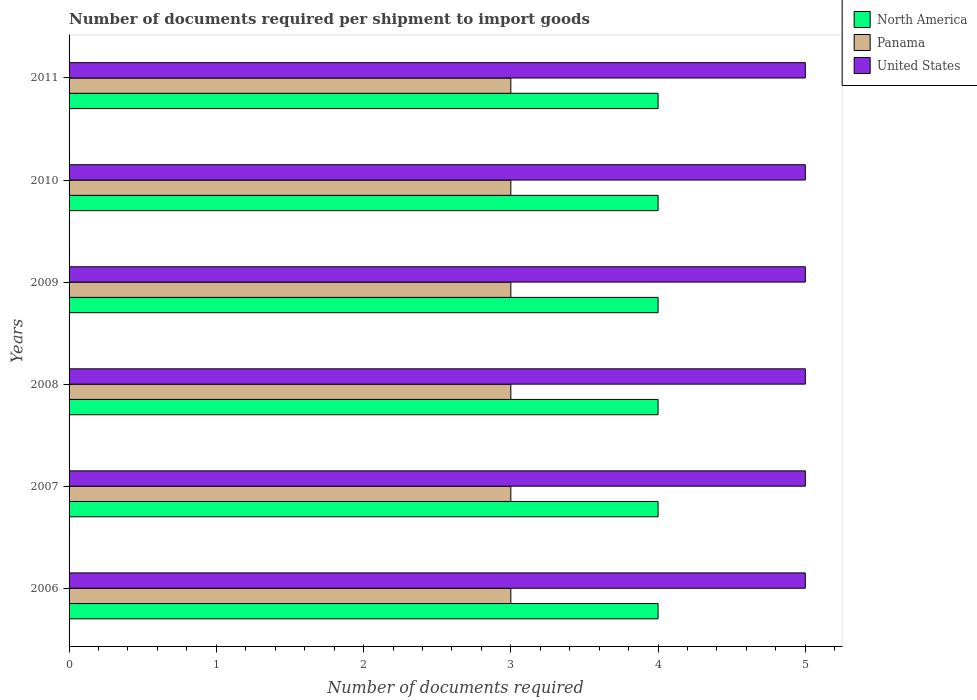How many different coloured bars are there?
Give a very brief answer. 3. Are the number of bars on each tick of the Y-axis equal?
Ensure brevity in your answer.  Yes. How many bars are there on the 3rd tick from the top?
Make the answer very short. 3. How many bars are there on the 4th tick from the bottom?
Provide a succinct answer. 3. What is the label of the 6th group of bars from the top?
Give a very brief answer. 2006. What is the number of documents required per shipment to import goods in Panama in 2006?
Your answer should be compact. 3. Across all years, what is the maximum number of documents required per shipment to import goods in United States?
Your answer should be compact. 5. Across all years, what is the minimum number of documents required per shipment to import goods in Panama?
Provide a short and direct response. 3. What is the total number of documents required per shipment to import goods in North America in the graph?
Give a very brief answer. 24. What is the difference between the number of documents required per shipment to import goods in Panama in 2006 and that in 2008?
Your answer should be compact. 0. What is the difference between the number of documents required per shipment to import goods in Panama in 2010 and the number of documents required per shipment to import goods in United States in 2007?
Give a very brief answer. -2. What is the average number of documents required per shipment to import goods in North America per year?
Keep it short and to the point. 4. In the year 2008, what is the difference between the number of documents required per shipment to import goods in North America and number of documents required per shipment to import goods in Panama?
Give a very brief answer. 1. In how many years, is the number of documents required per shipment to import goods in United States greater than 2.8 ?
Offer a very short reply. 6. What does the 2nd bar from the top in 2007 represents?
Your response must be concise. Panama. What does the 2nd bar from the bottom in 2009 represents?
Your answer should be compact. Panama. Is it the case that in every year, the sum of the number of documents required per shipment to import goods in North America and number of documents required per shipment to import goods in United States is greater than the number of documents required per shipment to import goods in Panama?
Give a very brief answer. Yes. How many bars are there?
Offer a terse response. 18. Are the values on the major ticks of X-axis written in scientific E-notation?
Offer a very short reply. No. Where does the legend appear in the graph?
Keep it short and to the point. Top right. What is the title of the graph?
Your response must be concise. Number of documents required per shipment to import goods. What is the label or title of the X-axis?
Provide a short and direct response. Number of documents required. What is the label or title of the Y-axis?
Offer a very short reply. Years. What is the Number of documents required in United States in 2006?
Your answer should be compact. 5. What is the Number of documents required of Panama in 2007?
Make the answer very short. 3. What is the Number of documents required of United States in 2010?
Your answer should be very brief. 5. Across all years, what is the maximum Number of documents required of Panama?
Offer a terse response. 3. Across all years, what is the maximum Number of documents required of United States?
Keep it short and to the point. 5. Across all years, what is the minimum Number of documents required of North America?
Your answer should be compact. 4. What is the total Number of documents required of North America in the graph?
Your answer should be compact. 24. What is the total Number of documents required of United States in the graph?
Ensure brevity in your answer.  30. What is the difference between the Number of documents required of North America in 2006 and that in 2007?
Keep it short and to the point. 0. What is the difference between the Number of documents required in Panama in 2006 and that in 2007?
Make the answer very short. 0. What is the difference between the Number of documents required of United States in 2006 and that in 2007?
Offer a terse response. 0. What is the difference between the Number of documents required of North America in 2006 and that in 2008?
Ensure brevity in your answer.  0. What is the difference between the Number of documents required of United States in 2006 and that in 2008?
Your response must be concise. 0. What is the difference between the Number of documents required in North America in 2006 and that in 2009?
Make the answer very short. 0. What is the difference between the Number of documents required in Panama in 2006 and that in 2009?
Provide a succinct answer. 0. What is the difference between the Number of documents required in United States in 2006 and that in 2009?
Your answer should be compact. 0. What is the difference between the Number of documents required in North America in 2006 and that in 2011?
Provide a succinct answer. 0. What is the difference between the Number of documents required of Panama in 2006 and that in 2011?
Your answer should be very brief. 0. What is the difference between the Number of documents required of North America in 2007 and that in 2008?
Provide a succinct answer. 0. What is the difference between the Number of documents required in Panama in 2007 and that in 2008?
Provide a succinct answer. 0. What is the difference between the Number of documents required of North America in 2007 and that in 2009?
Offer a terse response. 0. What is the difference between the Number of documents required of Panama in 2007 and that in 2009?
Provide a succinct answer. 0. What is the difference between the Number of documents required in United States in 2007 and that in 2009?
Provide a succinct answer. 0. What is the difference between the Number of documents required in United States in 2007 and that in 2010?
Provide a succinct answer. 0. What is the difference between the Number of documents required of North America in 2007 and that in 2011?
Ensure brevity in your answer.  0. What is the difference between the Number of documents required of Panama in 2007 and that in 2011?
Your response must be concise. 0. What is the difference between the Number of documents required of United States in 2007 and that in 2011?
Offer a terse response. 0. What is the difference between the Number of documents required of North America in 2008 and that in 2010?
Provide a succinct answer. 0. What is the difference between the Number of documents required in North America in 2008 and that in 2011?
Make the answer very short. 0. What is the difference between the Number of documents required in Panama in 2008 and that in 2011?
Make the answer very short. 0. What is the difference between the Number of documents required in United States in 2008 and that in 2011?
Your answer should be compact. 0. What is the difference between the Number of documents required in North America in 2009 and that in 2010?
Provide a short and direct response. 0. What is the difference between the Number of documents required of Panama in 2009 and that in 2010?
Keep it short and to the point. 0. What is the difference between the Number of documents required in United States in 2009 and that in 2010?
Keep it short and to the point. 0. What is the difference between the Number of documents required in North America in 2009 and that in 2011?
Keep it short and to the point. 0. What is the difference between the Number of documents required in North America in 2010 and that in 2011?
Offer a terse response. 0. What is the difference between the Number of documents required in North America in 2006 and the Number of documents required in Panama in 2007?
Offer a very short reply. 1. What is the difference between the Number of documents required in North America in 2006 and the Number of documents required in United States in 2007?
Make the answer very short. -1. What is the difference between the Number of documents required in Panama in 2006 and the Number of documents required in United States in 2007?
Provide a succinct answer. -2. What is the difference between the Number of documents required of North America in 2006 and the Number of documents required of Panama in 2008?
Offer a very short reply. 1. What is the difference between the Number of documents required in Panama in 2006 and the Number of documents required in United States in 2008?
Ensure brevity in your answer.  -2. What is the difference between the Number of documents required in North America in 2006 and the Number of documents required in Panama in 2009?
Make the answer very short. 1. What is the difference between the Number of documents required in Panama in 2006 and the Number of documents required in United States in 2009?
Your response must be concise. -2. What is the difference between the Number of documents required in North America in 2006 and the Number of documents required in United States in 2010?
Ensure brevity in your answer.  -1. What is the difference between the Number of documents required of North America in 2006 and the Number of documents required of Panama in 2011?
Ensure brevity in your answer.  1. What is the difference between the Number of documents required in North America in 2006 and the Number of documents required in United States in 2011?
Ensure brevity in your answer.  -1. What is the difference between the Number of documents required in North America in 2007 and the Number of documents required in Panama in 2008?
Make the answer very short. 1. What is the difference between the Number of documents required in North America in 2007 and the Number of documents required in United States in 2008?
Provide a succinct answer. -1. What is the difference between the Number of documents required of North America in 2007 and the Number of documents required of Panama in 2009?
Provide a short and direct response. 1. What is the difference between the Number of documents required of North America in 2007 and the Number of documents required of Panama in 2010?
Ensure brevity in your answer.  1. What is the difference between the Number of documents required of North America in 2007 and the Number of documents required of United States in 2010?
Ensure brevity in your answer.  -1. What is the difference between the Number of documents required of North America in 2008 and the Number of documents required of Panama in 2009?
Ensure brevity in your answer.  1. What is the difference between the Number of documents required in North America in 2008 and the Number of documents required in United States in 2009?
Your answer should be compact. -1. What is the difference between the Number of documents required in Panama in 2008 and the Number of documents required in United States in 2009?
Your answer should be very brief. -2. What is the difference between the Number of documents required of North America in 2008 and the Number of documents required of Panama in 2010?
Your answer should be very brief. 1. What is the difference between the Number of documents required of Panama in 2008 and the Number of documents required of United States in 2010?
Offer a very short reply. -2. What is the difference between the Number of documents required of Panama in 2008 and the Number of documents required of United States in 2011?
Your answer should be compact. -2. What is the difference between the Number of documents required of North America in 2009 and the Number of documents required of Panama in 2010?
Your answer should be compact. 1. What is the difference between the Number of documents required in North America in 2009 and the Number of documents required in United States in 2010?
Provide a succinct answer. -1. What is the difference between the Number of documents required in Panama in 2009 and the Number of documents required in United States in 2010?
Your response must be concise. -2. What is the difference between the Number of documents required in North America in 2009 and the Number of documents required in Panama in 2011?
Provide a short and direct response. 1. What is the difference between the Number of documents required of Panama in 2009 and the Number of documents required of United States in 2011?
Provide a succinct answer. -2. What is the difference between the Number of documents required of North America in 2010 and the Number of documents required of Panama in 2011?
Offer a very short reply. 1. What is the difference between the Number of documents required of Panama in 2010 and the Number of documents required of United States in 2011?
Give a very brief answer. -2. What is the average Number of documents required in North America per year?
Offer a terse response. 4. What is the average Number of documents required of Panama per year?
Ensure brevity in your answer.  3. What is the average Number of documents required of United States per year?
Provide a short and direct response. 5. In the year 2006, what is the difference between the Number of documents required in North America and Number of documents required in United States?
Your answer should be very brief. -1. In the year 2007, what is the difference between the Number of documents required in Panama and Number of documents required in United States?
Offer a terse response. -2. In the year 2008, what is the difference between the Number of documents required of North America and Number of documents required of United States?
Your answer should be compact. -1. In the year 2008, what is the difference between the Number of documents required in Panama and Number of documents required in United States?
Offer a terse response. -2. In the year 2009, what is the difference between the Number of documents required in North America and Number of documents required in United States?
Provide a succinct answer. -1. In the year 2010, what is the difference between the Number of documents required of Panama and Number of documents required of United States?
Ensure brevity in your answer.  -2. In the year 2011, what is the difference between the Number of documents required in North America and Number of documents required in Panama?
Your answer should be compact. 1. What is the ratio of the Number of documents required of North America in 2006 to that in 2007?
Offer a terse response. 1. What is the ratio of the Number of documents required of United States in 2006 to that in 2007?
Ensure brevity in your answer.  1. What is the ratio of the Number of documents required in North America in 2006 to that in 2008?
Ensure brevity in your answer.  1. What is the ratio of the Number of documents required of Panama in 2006 to that in 2008?
Provide a short and direct response. 1. What is the ratio of the Number of documents required of United States in 2006 to that in 2008?
Provide a short and direct response. 1. What is the ratio of the Number of documents required of Panama in 2006 to that in 2009?
Keep it short and to the point. 1. What is the ratio of the Number of documents required in United States in 2006 to that in 2009?
Give a very brief answer. 1. What is the ratio of the Number of documents required of North America in 2006 to that in 2010?
Your response must be concise. 1. What is the ratio of the Number of documents required of Panama in 2006 to that in 2010?
Offer a very short reply. 1. What is the ratio of the Number of documents required in United States in 2006 to that in 2010?
Ensure brevity in your answer.  1. What is the ratio of the Number of documents required of North America in 2007 to that in 2008?
Provide a succinct answer. 1. What is the ratio of the Number of documents required of United States in 2007 to that in 2008?
Ensure brevity in your answer.  1. What is the ratio of the Number of documents required in North America in 2007 to that in 2009?
Offer a terse response. 1. What is the ratio of the Number of documents required in North America in 2007 to that in 2010?
Provide a short and direct response. 1. What is the ratio of the Number of documents required of Panama in 2007 to that in 2010?
Offer a very short reply. 1. What is the ratio of the Number of documents required in United States in 2007 to that in 2010?
Provide a succinct answer. 1. What is the ratio of the Number of documents required of Panama in 2007 to that in 2011?
Make the answer very short. 1. What is the ratio of the Number of documents required of North America in 2008 to that in 2009?
Your response must be concise. 1. What is the ratio of the Number of documents required in Panama in 2008 to that in 2009?
Offer a very short reply. 1. What is the ratio of the Number of documents required of Panama in 2008 to that in 2010?
Offer a terse response. 1. What is the ratio of the Number of documents required in United States in 2008 to that in 2010?
Your response must be concise. 1. What is the ratio of the Number of documents required of North America in 2008 to that in 2011?
Your answer should be compact. 1. What is the ratio of the Number of documents required in North America in 2009 to that in 2010?
Your answer should be compact. 1. What is the ratio of the Number of documents required of Panama in 2009 to that in 2010?
Ensure brevity in your answer.  1. What is the ratio of the Number of documents required of United States in 2009 to that in 2010?
Provide a short and direct response. 1. What is the ratio of the Number of documents required in North America in 2010 to that in 2011?
Provide a short and direct response. 1. What is the ratio of the Number of documents required of Panama in 2010 to that in 2011?
Provide a short and direct response. 1. What is the difference between the highest and the lowest Number of documents required in United States?
Offer a very short reply. 0. 